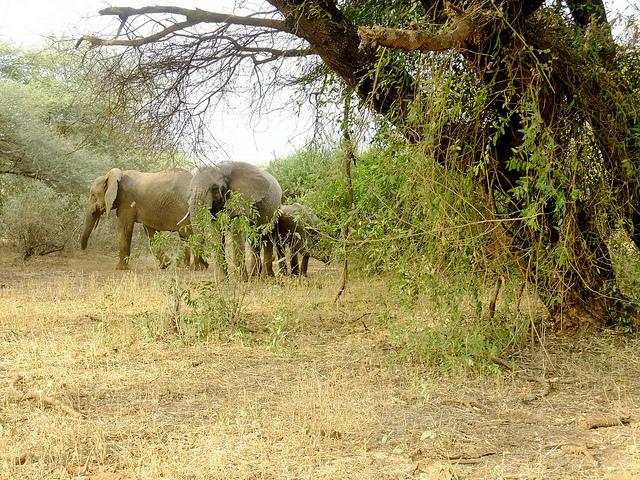How many elephants are huddled together on the left side of the hanging tree?

Choices:
A) six
B) five
C) four
D) three three 